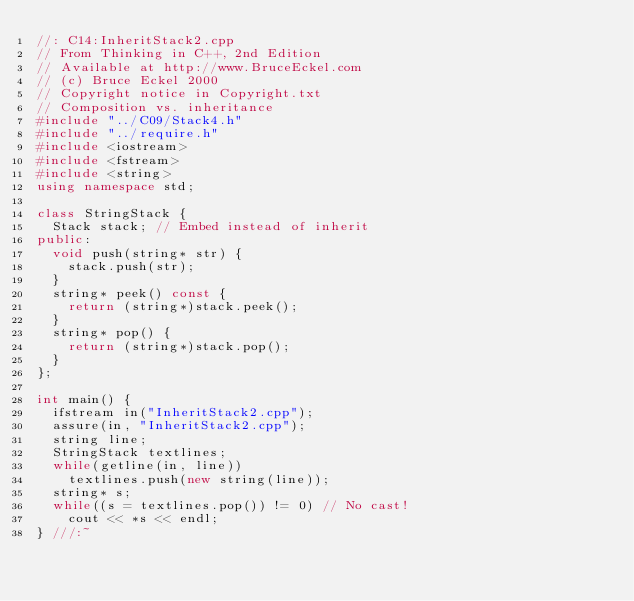Convert code to text. <code><loc_0><loc_0><loc_500><loc_500><_C++_>//: C14:InheritStack2.cpp
// From Thinking in C++, 2nd Edition
// Available at http://www.BruceEckel.com
// (c) Bruce Eckel 2000
// Copyright notice in Copyright.txt
// Composition vs. inheritance
#include "../C09/Stack4.h"
#include "../require.h"
#include <iostream>
#include <fstream>
#include <string>
using namespace std;

class StringStack {
  Stack stack; // Embed instead of inherit
public:
  void push(string* str) {
    stack.push(str);
  }
  string* peek() const {
    return (string*)stack.peek();
  }
  string* pop() {
    return (string*)stack.pop();
  }
};

int main() {
  ifstream in("InheritStack2.cpp");
  assure(in, "InheritStack2.cpp");
  string line;
  StringStack textlines;
  while(getline(in, line))
    textlines.push(new string(line));
  string* s;
  while((s = textlines.pop()) != 0) // No cast!
    cout << *s << endl;
} ///:~
</code> 